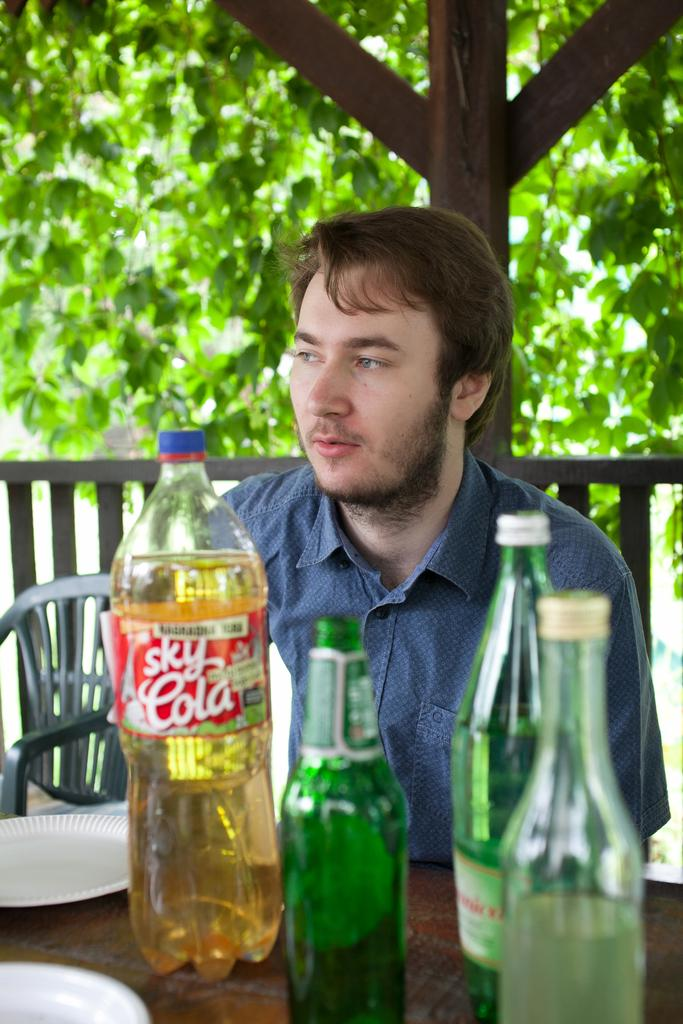<image>
Write a terse but informative summary of the picture. A man sits at a table behind a large bottle of Sky Cola. 